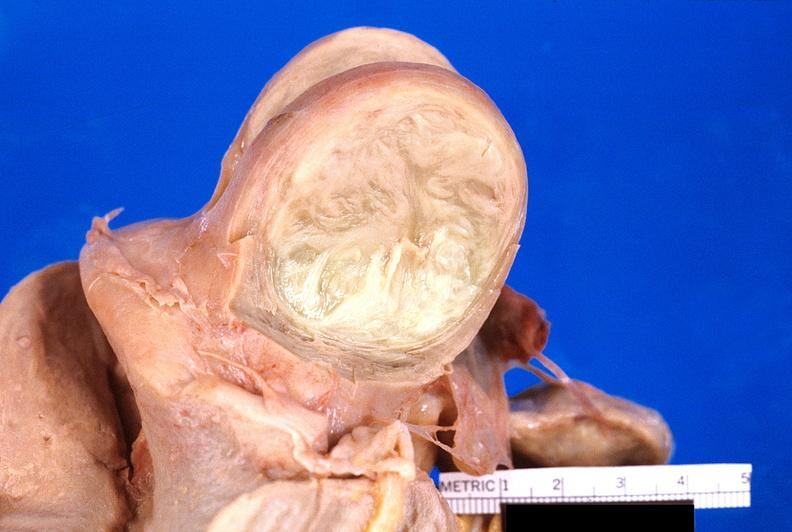where does this part belong to?
Answer the question using a single word or phrase. Female reproductive system 